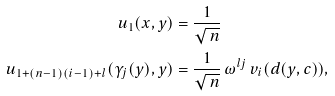<formula> <loc_0><loc_0><loc_500><loc_500>u _ { 1 } ( x , y ) & = \frac { 1 } { \sqrt { \, n } } \\ u _ { 1 + ( n - 1 ) ( i - 1 ) + l } ( \gamma _ { j } ( y ) , y ) & = \frac { 1 } { \sqrt { \, n } } \, \omega ^ { l j } \, v _ { i } ( d ( y , c ) ) ,</formula> 